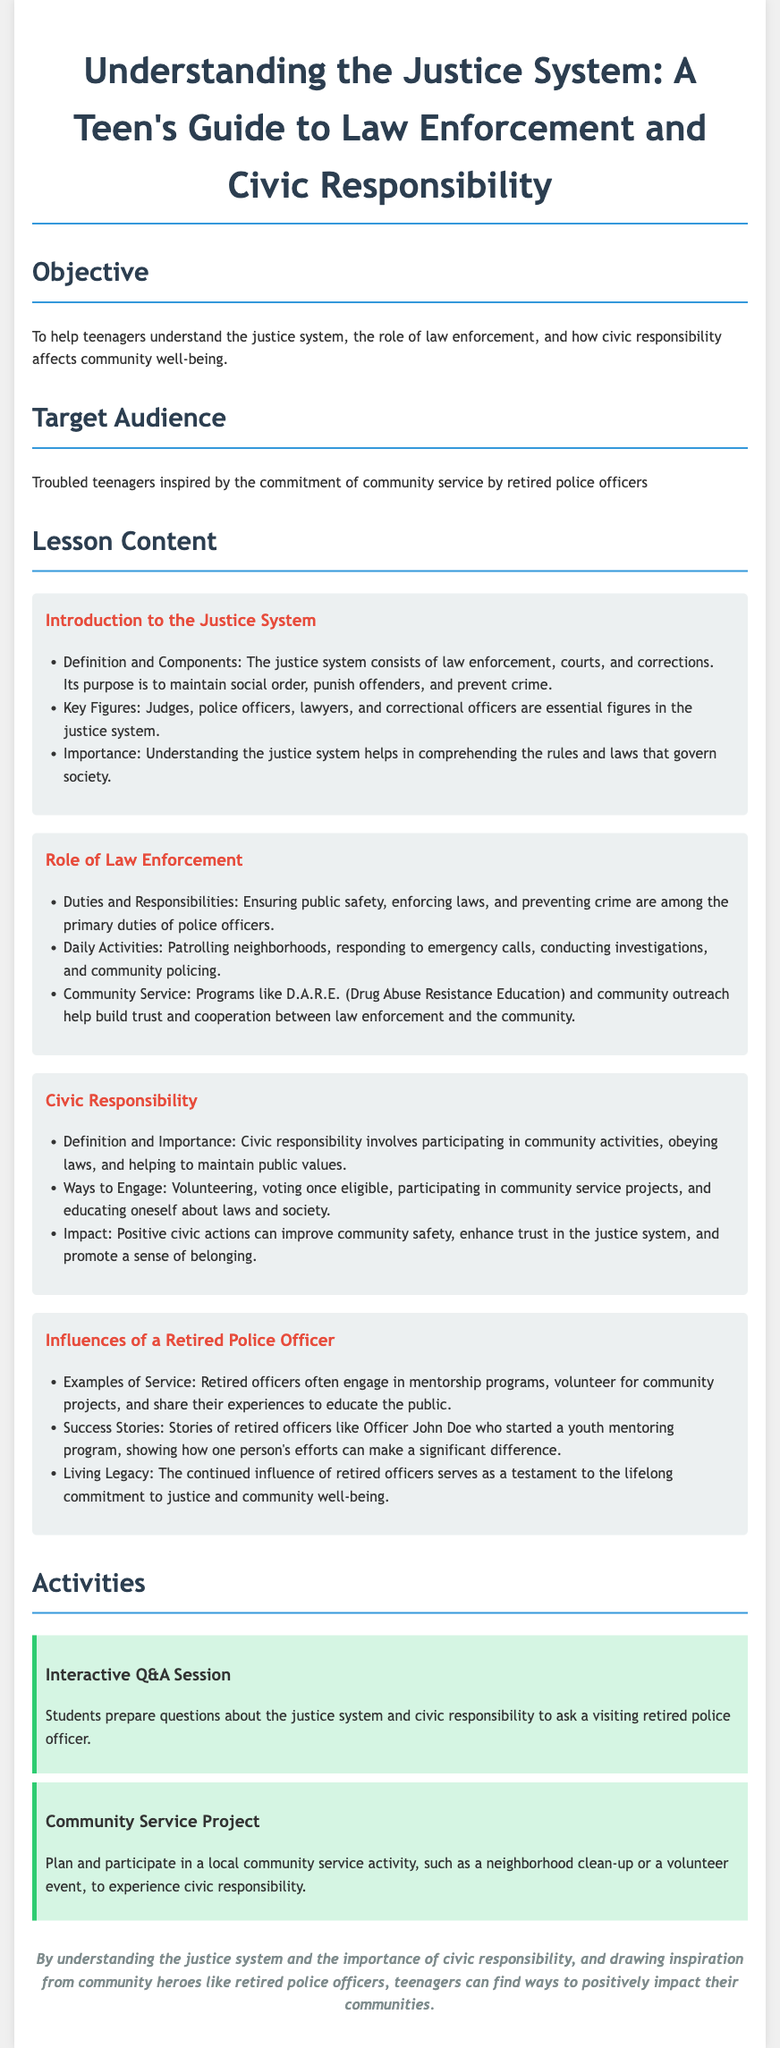What is the objective of the lesson? The objective of the lesson is to help teenagers understand the justice system, the role of law enforcement, and how civic responsibility affects community well-being.
Answer: To help teenagers understand the justice system, the role of law enforcement, and how civic responsibility affects community well-being Who are the key figures mentioned in the justice system? Key figures in the justice system include judges, police officers, lawyers, and correctional officers.
Answer: Judges, police officers, lawyers, and correctional officers What is one of the primary duties of police officers? A primary duty of police officers is ensuring public safety.
Answer: Ensuring public safety What does civic responsibility involve? Civic responsibility involves participating in community activities, obeying laws, and helping to maintain public values.
Answer: Participating in community activities, obeying laws, and helping to maintain public values Name one example of a program mentioned that helps build trust between law enforcement and the community. One example of a program is D.A.R.E. (Drug Abuse Resistance Education).
Answer: D.A.R.E. (Drug Abuse Resistance Education) What is a way mentioned to engage in civic responsibility? One way to engage in civic responsibility is by volunteering.
Answer: Volunteering Who is an example of a retired police officer noted in the document? An example is Officer John Doe.
Answer: Officer John Doe What type of activity is suggested for a community service project? A suggested activity is a neighborhood clean-up or a volunteer event.
Answer: Neighborhood clean-up or a volunteer event 